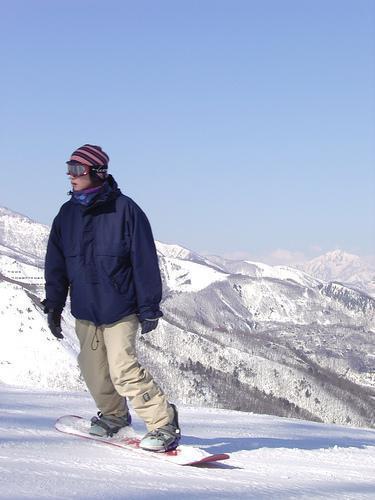How many people are there?
Give a very brief answer. 1. How many knives to the left?
Give a very brief answer. 0. 